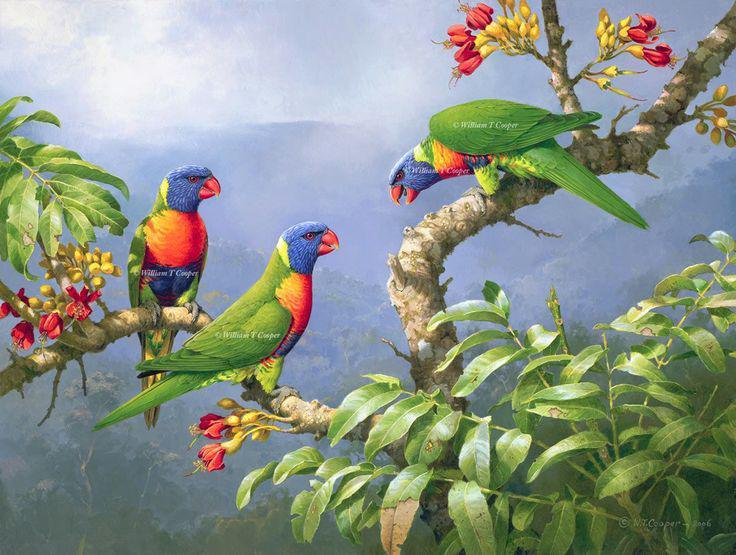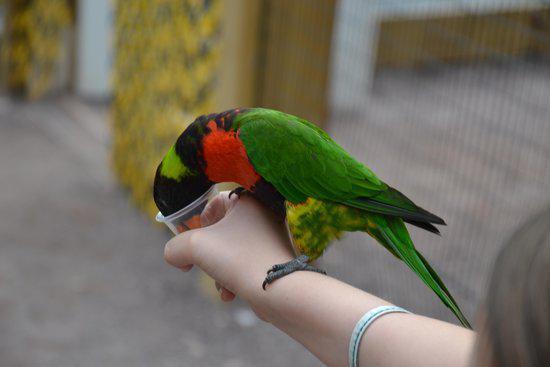The first image is the image on the left, the second image is the image on the right. Given the left and right images, does the statement "An image shows a single parrot which is not in flight." hold true? Answer yes or no. Yes. 